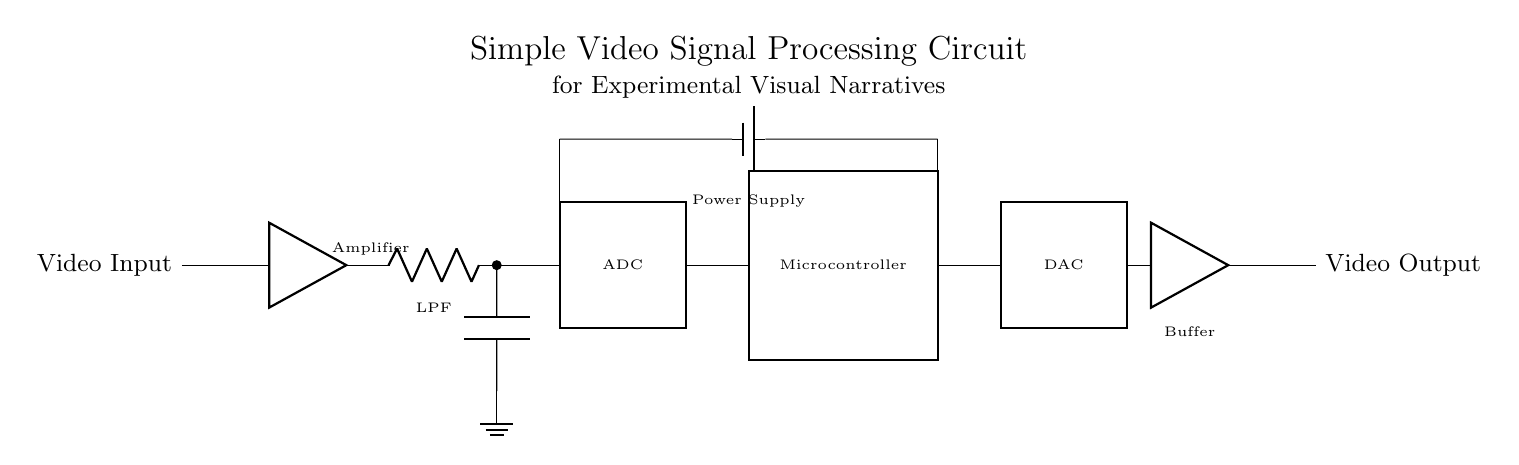What is the first component in this circuit? The first component is the video input, which is located at the left side of the circuit diagram.
Answer: Video Input What component follows the amplifier in the signal path? After the amplifier, the low-pass filter is connected, which is important for filtering out high-frequency noise from the video signal.
Answer: Low-Pass Filter What does the ADC do in this circuit? The ADC, or Analog-to-Digital Converter, converts the analog video signal to a digital format for processing by the microcontroller, which is crucial for digital manipulation and storage of video data.
Answer: Converts analog to digital How many main blocks are present in this circuit? The circuit diagram consists of six main blocks: Video Input, Amplifier, Low-Pass Filter, ADC, Microcontroller, and DAC, which are all essential for the video signal processing workflow.
Answer: Six What is the function of the Buffer in this circuit? The Buffer amplifies the processed digital signal to ensure that the output video signal is strong enough for output display, maintaining signal integrity for the final output.
Answer: Amplifies output Which component directly outputs the video signal? The component that directly outputs the video signal is the Buffer which ensures that the signal is ready for output after processing by the microcontroller.
Answer: Buffer 